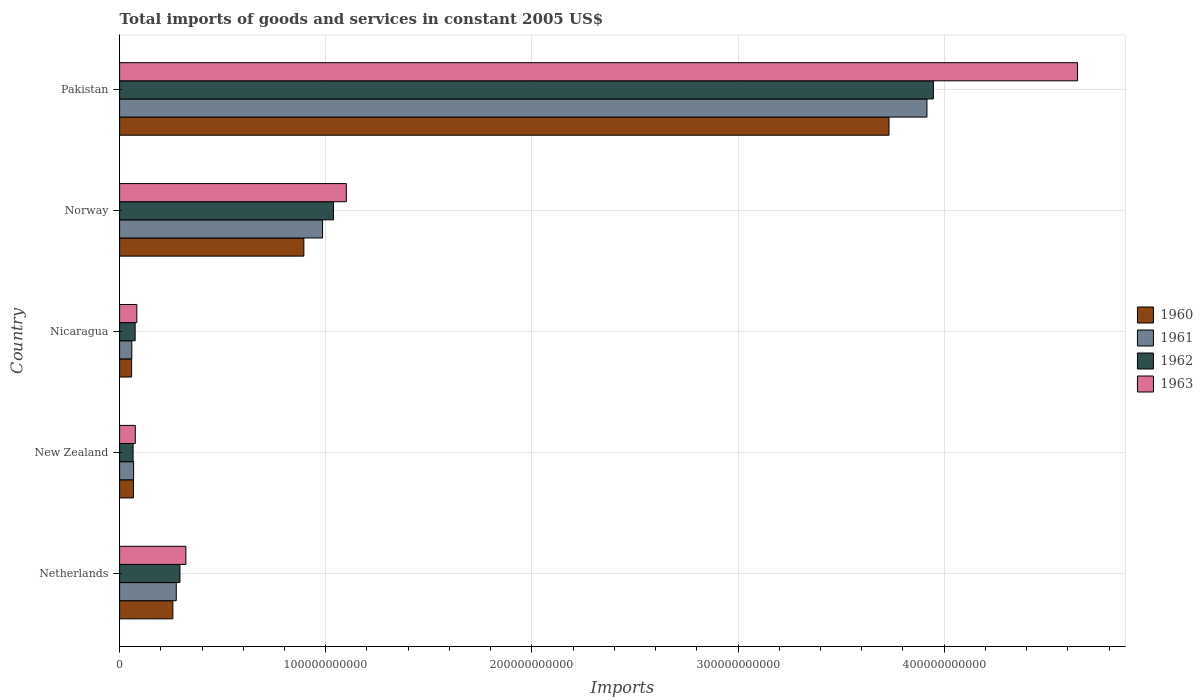How many different coloured bars are there?
Make the answer very short. 4. How many groups of bars are there?
Your answer should be compact. 5. Are the number of bars per tick equal to the number of legend labels?
Ensure brevity in your answer.  Yes. Are the number of bars on each tick of the Y-axis equal?
Ensure brevity in your answer.  Yes. How many bars are there on the 4th tick from the top?
Provide a short and direct response. 4. How many bars are there on the 2nd tick from the bottom?
Keep it short and to the point. 4. What is the total imports of goods and services in 1963 in Norway?
Provide a succinct answer. 1.10e+11. Across all countries, what is the maximum total imports of goods and services in 1962?
Provide a succinct answer. 3.95e+11. Across all countries, what is the minimum total imports of goods and services in 1963?
Your answer should be compact. 7.62e+09. In which country was the total imports of goods and services in 1961 minimum?
Make the answer very short. Nicaragua. What is the total total imports of goods and services in 1963 in the graph?
Offer a terse response. 6.23e+11. What is the difference between the total imports of goods and services in 1963 in Netherlands and that in New Zealand?
Your response must be concise. 2.45e+1. What is the difference between the total imports of goods and services in 1960 in Nicaragua and the total imports of goods and services in 1962 in New Zealand?
Ensure brevity in your answer.  -7.05e+08. What is the average total imports of goods and services in 1960 per country?
Give a very brief answer. 1.00e+11. What is the difference between the total imports of goods and services in 1961 and total imports of goods and services in 1960 in Norway?
Your response must be concise. 9.07e+09. In how many countries, is the total imports of goods and services in 1961 greater than 200000000000 US$?
Offer a very short reply. 1. What is the ratio of the total imports of goods and services in 1960 in New Zealand to that in Nicaragua?
Give a very brief answer. 1.15. Is the total imports of goods and services in 1961 in Netherlands less than that in Pakistan?
Your answer should be very brief. Yes. Is the difference between the total imports of goods and services in 1961 in Netherlands and Norway greater than the difference between the total imports of goods and services in 1960 in Netherlands and Norway?
Offer a terse response. No. What is the difference between the highest and the second highest total imports of goods and services in 1962?
Offer a terse response. 2.91e+11. What is the difference between the highest and the lowest total imports of goods and services in 1963?
Offer a very short reply. 4.57e+11. In how many countries, is the total imports of goods and services in 1960 greater than the average total imports of goods and services in 1960 taken over all countries?
Provide a short and direct response. 1. Is it the case that in every country, the sum of the total imports of goods and services in 1961 and total imports of goods and services in 1962 is greater than the sum of total imports of goods and services in 1963 and total imports of goods and services in 1960?
Your answer should be compact. No. What does the 1st bar from the bottom in Netherlands represents?
Ensure brevity in your answer.  1960. How many bars are there?
Give a very brief answer. 20. What is the difference between two consecutive major ticks on the X-axis?
Offer a terse response. 1.00e+11. How are the legend labels stacked?
Make the answer very short. Vertical. What is the title of the graph?
Offer a terse response. Total imports of goods and services in constant 2005 US$. Does "1972" appear as one of the legend labels in the graph?
Give a very brief answer. No. What is the label or title of the X-axis?
Make the answer very short. Imports. What is the Imports in 1960 in Netherlands?
Your response must be concise. 2.58e+1. What is the Imports of 1961 in Netherlands?
Keep it short and to the point. 2.75e+1. What is the Imports of 1962 in Netherlands?
Ensure brevity in your answer.  2.93e+1. What is the Imports of 1963 in Netherlands?
Provide a succinct answer. 3.21e+1. What is the Imports in 1960 in New Zealand?
Ensure brevity in your answer.  6.71e+09. What is the Imports in 1961 in New Zealand?
Provide a succinct answer. 6.81e+09. What is the Imports in 1962 in New Zealand?
Provide a short and direct response. 6.55e+09. What is the Imports of 1963 in New Zealand?
Keep it short and to the point. 7.62e+09. What is the Imports of 1960 in Nicaragua?
Your answer should be compact. 5.84e+09. What is the Imports in 1961 in Nicaragua?
Ensure brevity in your answer.  5.92e+09. What is the Imports in 1962 in Nicaragua?
Give a very brief answer. 7.54e+09. What is the Imports in 1963 in Nicaragua?
Your answer should be very brief. 8.36e+09. What is the Imports in 1960 in Norway?
Your answer should be very brief. 8.94e+1. What is the Imports in 1961 in Norway?
Your answer should be very brief. 9.85e+1. What is the Imports in 1962 in Norway?
Give a very brief answer. 1.04e+11. What is the Imports in 1963 in Norway?
Offer a very short reply. 1.10e+11. What is the Imports of 1960 in Pakistan?
Your response must be concise. 3.73e+11. What is the Imports in 1961 in Pakistan?
Provide a succinct answer. 3.92e+11. What is the Imports in 1962 in Pakistan?
Ensure brevity in your answer.  3.95e+11. What is the Imports in 1963 in Pakistan?
Provide a short and direct response. 4.65e+11. Across all countries, what is the maximum Imports of 1960?
Offer a terse response. 3.73e+11. Across all countries, what is the maximum Imports in 1961?
Your answer should be very brief. 3.92e+11. Across all countries, what is the maximum Imports of 1962?
Give a very brief answer. 3.95e+11. Across all countries, what is the maximum Imports in 1963?
Your answer should be compact. 4.65e+11. Across all countries, what is the minimum Imports of 1960?
Give a very brief answer. 5.84e+09. Across all countries, what is the minimum Imports in 1961?
Your answer should be compact. 5.92e+09. Across all countries, what is the minimum Imports of 1962?
Your answer should be compact. 6.55e+09. Across all countries, what is the minimum Imports in 1963?
Provide a succinct answer. 7.62e+09. What is the total Imports of 1960 in the graph?
Ensure brevity in your answer.  5.01e+11. What is the total Imports of 1961 in the graph?
Ensure brevity in your answer.  5.30e+11. What is the total Imports of 1962 in the graph?
Provide a succinct answer. 5.42e+11. What is the total Imports in 1963 in the graph?
Provide a short and direct response. 6.23e+11. What is the difference between the Imports of 1960 in Netherlands and that in New Zealand?
Give a very brief answer. 1.91e+1. What is the difference between the Imports in 1961 in Netherlands and that in New Zealand?
Your answer should be compact. 2.07e+1. What is the difference between the Imports of 1962 in Netherlands and that in New Zealand?
Your answer should be very brief. 2.27e+1. What is the difference between the Imports of 1963 in Netherlands and that in New Zealand?
Provide a short and direct response. 2.45e+1. What is the difference between the Imports of 1960 in Netherlands and that in Nicaragua?
Offer a very short reply. 2.00e+1. What is the difference between the Imports of 1961 in Netherlands and that in Nicaragua?
Keep it short and to the point. 2.16e+1. What is the difference between the Imports of 1962 in Netherlands and that in Nicaragua?
Keep it short and to the point. 2.17e+1. What is the difference between the Imports in 1963 in Netherlands and that in Nicaragua?
Give a very brief answer. 2.38e+1. What is the difference between the Imports of 1960 in Netherlands and that in Norway?
Your answer should be very brief. -6.35e+1. What is the difference between the Imports in 1961 in Netherlands and that in Norway?
Your response must be concise. -7.10e+1. What is the difference between the Imports of 1962 in Netherlands and that in Norway?
Your response must be concise. -7.45e+1. What is the difference between the Imports in 1963 in Netherlands and that in Norway?
Provide a succinct answer. -7.78e+1. What is the difference between the Imports in 1960 in Netherlands and that in Pakistan?
Keep it short and to the point. -3.47e+11. What is the difference between the Imports of 1961 in Netherlands and that in Pakistan?
Your answer should be very brief. -3.64e+11. What is the difference between the Imports in 1962 in Netherlands and that in Pakistan?
Offer a very short reply. -3.66e+11. What is the difference between the Imports in 1963 in Netherlands and that in Pakistan?
Your answer should be compact. -4.33e+11. What is the difference between the Imports of 1960 in New Zealand and that in Nicaragua?
Offer a terse response. 8.66e+08. What is the difference between the Imports of 1961 in New Zealand and that in Nicaragua?
Keep it short and to the point. 8.81e+08. What is the difference between the Imports in 1962 in New Zealand and that in Nicaragua?
Your answer should be very brief. -9.91e+08. What is the difference between the Imports of 1963 in New Zealand and that in Nicaragua?
Your answer should be very brief. -7.46e+08. What is the difference between the Imports in 1960 in New Zealand and that in Norway?
Provide a short and direct response. -8.27e+1. What is the difference between the Imports in 1961 in New Zealand and that in Norway?
Your response must be concise. -9.17e+1. What is the difference between the Imports of 1962 in New Zealand and that in Norway?
Keep it short and to the point. -9.72e+1. What is the difference between the Imports of 1963 in New Zealand and that in Norway?
Keep it short and to the point. -1.02e+11. What is the difference between the Imports in 1960 in New Zealand and that in Pakistan?
Your answer should be compact. -3.67e+11. What is the difference between the Imports in 1961 in New Zealand and that in Pakistan?
Provide a short and direct response. -3.85e+11. What is the difference between the Imports of 1962 in New Zealand and that in Pakistan?
Provide a short and direct response. -3.88e+11. What is the difference between the Imports of 1963 in New Zealand and that in Pakistan?
Give a very brief answer. -4.57e+11. What is the difference between the Imports in 1960 in Nicaragua and that in Norway?
Provide a short and direct response. -8.35e+1. What is the difference between the Imports of 1961 in Nicaragua and that in Norway?
Ensure brevity in your answer.  -9.25e+1. What is the difference between the Imports in 1962 in Nicaragua and that in Norway?
Keep it short and to the point. -9.62e+1. What is the difference between the Imports of 1963 in Nicaragua and that in Norway?
Offer a terse response. -1.02e+11. What is the difference between the Imports of 1960 in Nicaragua and that in Pakistan?
Your answer should be very brief. -3.67e+11. What is the difference between the Imports in 1961 in Nicaragua and that in Pakistan?
Offer a very short reply. -3.86e+11. What is the difference between the Imports of 1962 in Nicaragua and that in Pakistan?
Your response must be concise. -3.87e+11. What is the difference between the Imports of 1963 in Nicaragua and that in Pakistan?
Keep it short and to the point. -4.56e+11. What is the difference between the Imports in 1960 in Norway and that in Pakistan?
Ensure brevity in your answer.  -2.84e+11. What is the difference between the Imports in 1961 in Norway and that in Pakistan?
Your answer should be compact. -2.93e+11. What is the difference between the Imports in 1962 in Norway and that in Pakistan?
Provide a short and direct response. -2.91e+11. What is the difference between the Imports in 1963 in Norway and that in Pakistan?
Offer a very short reply. -3.55e+11. What is the difference between the Imports of 1960 in Netherlands and the Imports of 1961 in New Zealand?
Keep it short and to the point. 1.90e+1. What is the difference between the Imports of 1960 in Netherlands and the Imports of 1962 in New Zealand?
Provide a short and direct response. 1.93e+1. What is the difference between the Imports of 1960 in Netherlands and the Imports of 1963 in New Zealand?
Provide a succinct answer. 1.82e+1. What is the difference between the Imports in 1961 in Netherlands and the Imports in 1962 in New Zealand?
Offer a terse response. 2.10e+1. What is the difference between the Imports of 1961 in Netherlands and the Imports of 1963 in New Zealand?
Give a very brief answer. 1.99e+1. What is the difference between the Imports of 1962 in Netherlands and the Imports of 1963 in New Zealand?
Offer a terse response. 2.17e+1. What is the difference between the Imports of 1960 in Netherlands and the Imports of 1961 in Nicaragua?
Keep it short and to the point. 1.99e+1. What is the difference between the Imports in 1960 in Netherlands and the Imports in 1962 in Nicaragua?
Provide a short and direct response. 1.83e+1. What is the difference between the Imports of 1960 in Netherlands and the Imports of 1963 in Nicaragua?
Your answer should be compact. 1.75e+1. What is the difference between the Imports in 1961 in Netherlands and the Imports in 1962 in Nicaragua?
Your response must be concise. 2.00e+1. What is the difference between the Imports in 1961 in Netherlands and the Imports in 1963 in Nicaragua?
Give a very brief answer. 1.91e+1. What is the difference between the Imports in 1962 in Netherlands and the Imports in 1963 in Nicaragua?
Your answer should be very brief. 2.09e+1. What is the difference between the Imports in 1960 in Netherlands and the Imports in 1961 in Norway?
Your answer should be very brief. -7.26e+1. What is the difference between the Imports in 1960 in Netherlands and the Imports in 1962 in Norway?
Your answer should be compact. -7.79e+1. What is the difference between the Imports of 1960 in Netherlands and the Imports of 1963 in Norway?
Give a very brief answer. -8.41e+1. What is the difference between the Imports in 1961 in Netherlands and the Imports in 1962 in Norway?
Your answer should be compact. -7.62e+1. What is the difference between the Imports in 1961 in Netherlands and the Imports in 1963 in Norway?
Your answer should be compact. -8.25e+1. What is the difference between the Imports of 1962 in Netherlands and the Imports of 1963 in Norway?
Give a very brief answer. -8.07e+1. What is the difference between the Imports of 1960 in Netherlands and the Imports of 1961 in Pakistan?
Provide a short and direct response. -3.66e+11. What is the difference between the Imports of 1960 in Netherlands and the Imports of 1962 in Pakistan?
Your answer should be compact. -3.69e+11. What is the difference between the Imports of 1960 in Netherlands and the Imports of 1963 in Pakistan?
Ensure brevity in your answer.  -4.39e+11. What is the difference between the Imports in 1961 in Netherlands and the Imports in 1962 in Pakistan?
Make the answer very short. -3.67e+11. What is the difference between the Imports of 1961 in Netherlands and the Imports of 1963 in Pakistan?
Your answer should be very brief. -4.37e+11. What is the difference between the Imports of 1962 in Netherlands and the Imports of 1963 in Pakistan?
Provide a short and direct response. -4.35e+11. What is the difference between the Imports of 1960 in New Zealand and the Imports of 1961 in Nicaragua?
Make the answer very short. 7.83e+08. What is the difference between the Imports in 1960 in New Zealand and the Imports in 1962 in Nicaragua?
Provide a short and direct response. -8.30e+08. What is the difference between the Imports in 1960 in New Zealand and the Imports in 1963 in Nicaragua?
Make the answer very short. -1.66e+09. What is the difference between the Imports of 1961 in New Zealand and the Imports of 1962 in Nicaragua?
Ensure brevity in your answer.  -7.32e+08. What is the difference between the Imports of 1961 in New Zealand and the Imports of 1963 in Nicaragua?
Provide a succinct answer. -1.56e+09. What is the difference between the Imports of 1962 in New Zealand and the Imports of 1963 in Nicaragua?
Your response must be concise. -1.82e+09. What is the difference between the Imports of 1960 in New Zealand and the Imports of 1961 in Norway?
Offer a very short reply. -9.18e+1. What is the difference between the Imports in 1960 in New Zealand and the Imports in 1962 in Norway?
Offer a very short reply. -9.70e+1. What is the difference between the Imports of 1960 in New Zealand and the Imports of 1963 in Norway?
Your response must be concise. -1.03e+11. What is the difference between the Imports in 1961 in New Zealand and the Imports in 1962 in Norway?
Offer a terse response. -9.69e+1. What is the difference between the Imports in 1961 in New Zealand and the Imports in 1963 in Norway?
Your answer should be very brief. -1.03e+11. What is the difference between the Imports in 1962 in New Zealand and the Imports in 1963 in Norway?
Your response must be concise. -1.03e+11. What is the difference between the Imports of 1960 in New Zealand and the Imports of 1961 in Pakistan?
Keep it short and to the point. -3.85e+11. What is the difference between the Imports in 1960 in New Zealand and the Imports in 1962 in Pakistan?
Your answer should be compact. -3.88e+11. What is the difference between the Imports in 1960 in New Zealand and the Imports in 1963 in Pakistan?
Keep it short and to the point. -4.58e+11. What is the difference between the Imports of 1961 in New Zealand and the Imports of 1962 in Pakistan?
Offer a very short reply. -3.88e+11. What is the difference between the Imports in 1961 in New Zealand and the Imports in 1963 in Pakistan?
Give a very brief answer. -4.58e+11. What is the difference between the Imports of 1962 in New Zealand and the Imports of 1963 in Pakistan?
Your answer should be compact. -4.58e+11. What is the difference between the Imports in 1960 in Nicaragua and the Imports in 1961 in Norway?
Offer a very short reply. -9.26e+1. What is the difference between the Imports of 1960 in Nicaragua and the Imports of 1962 in Norway?
Your answer should be compact. -9.79e+1. What is the difference between the Imports of 1960 in Nicaragua and the Imports of 1963 in Norway?
Your answer should be compact. -1.04e+11. What is the difference between the Imports in 1961 in Nicaragua and the Imports in 1962 in Norway?
Offer a very short reply. -9.78e+1. What is the difference between the Imports of 1961 in Nicaragua and the Imports of 1963 in Norway?
Your response must be concise. -1.04e+11. What is the difference between the Imports in 1962 in Nicaragua and the Imports in 1963 in Norway?
Keep it short and to the point. -1.02e+11. What is the difference between the Imports in 1960 in Nicaragua and the Imports in 1961 in Pakistan?
Give a very brief answer. -3.86e+11. What is the difference between the Imports of 1960 in Nicaragua and the Imports of 1962 in Pakistan?
Your answer should be very brief. -3.89e+11. What is the difference between the Imports of 1960 in Nicaragua and the Imports of 1963 in Pakistan?
Offer a terse response. -4.59e+11. What is the difference between the Imports of 1961 in Nicaragua and the Imports of 1962 in Pakistan?
Give a very brief answer. -3.89e+11. What is the difference between the Imports in 1961 in Nicaragua and the Imports in 1963 in Pakistan?
Provide a succinct answer. -4.59e+11. What is the difference between the Imports in 1962 in Nicaragua and the Imports in 1963 in Pakistan?
Provide a succinct answer. -4.57e+11. What is the difference between the Imports of 1960 in Norway and the Imports of 1961 in Pakistan?
Keep it short and to the point. -3.02e+11. What is the difference between the Imports in 1960 in Norway and the Imports in 1962 in Pakistan?
Your answer should be compact. -3.05e+11. What is the difference between the Imports of 1960 in Norway and the Imports of 1963 in Pakistan?
Your response must be concise. -3.75e+11. What is the difference between the Imports in 1961 in Norway and the Imports in 1962 in Pakistan?
Offer a terse response. -2.96e+11. What is the difference between the Imports of 1961 in Norway and the Imports of 1963 in Pakistan?
Make the answer very short. -3.66e+11. What is the difference between the Imports in 1962 in Norway and the Imports in 1963 in Pakistan?
Give a very brief answer. -3.61e+11. What is the average Imports of 1960 per country?
Offer a terse response. 1.00e+11. What is the average Imports in 1961 per country?
Provide a succinct answer. 1.06e+11. What is the average Imports of 1962 per country?
Your response must be concise. 1.08e+11. What is the average Imports of 1963 per country?
Your answer should be compact. 1.25e+11. What is the difference between the Imports of 1960 and Imports of 1961 in Netherlands?
Your answer should be very brief. -1.65e+09. What is the difference between the Imports of 1960 and Imports of 1962 in Netherlands?
Offer a terse response. -3.43e+09. What is the difference between the Imports of 1960 and Imports of 1963 in Netherlands?
Your response must be concise. -6.30e+09. What is the difference between the Imports in 1961 and Imports in 1962 in Netherlands?
Provide a succinct answer. -1.77e+09. What is the difference between the Imports in 1961 and Imports in 1963 in Netherlands?
Your response must be concise. -4.65e+09. What is the difference between the Imports in 1962 and Imports in 1963 in Netherlands?
Offer a terse response. -2.87e+09. What is the difference between the Imports of 1960 and Imports of 1961 in New Zealand?
Provide a succinct answer. -9.87e+07. What is the difference between the Imports of 1960 and Imports of 1962 in New Zealand?
Give a very brief answer. 1.61e+08. What is the difference between the Imports of 1960 and Imports of 1963 in New Zealand?
Your answer should be compact. -9.09e+08. What is the difference between the Imports of 1961 and Imports of 1962 in New Zealand?
Ensure brevity in your answer.  2.60e+08. What is the difference between the Imports of 1961 and Imports of 1963 in New Zealand?
Provide a short and direct response. -8.10e+08. What is the difference between the Imports of 1962 and Imports of 1963 in New Zealand?
Make the answer very short. -1.07e+09. What is the difference between the Imports of 1960 and Imports of 1961 in Nicaragua?
Provide a short and direct response. -8.34e+07. What is the difference between the Imports in 1960 and Imports in 1962 in Nicaragua?
Your answer should be very brief. -1.70e+09. What is the difference between the Imports in 1960 and Imports in 1963 in Nicaragua?
Make the answer very short. -2.52e+09. What is the difference between the Imports in 1961 and Imports in 1962 in Nicaragua?
Make the answer very short. -1.61e+09. What is the difference between the Imports of 1961 and Imports of 1963 in Nicaragua?
Ensure brevity in your answer.  -2.44e+09. What is the difference between the Imports of 1962 and Imports of 1963 in Nicaragua?
Provide a succinct answer. -8.25e+08. What is the difference between the Imports of 1960 and Imports of 1961 in Norway?
Your answer should be compact. -9.07e+09. What is the difference between the Imports in 1960 and Imports in 1962 in Norway?
Keep it short and to the point. -1.44e+1. What is the difference between the Imports of 1960 and Imports of 1963 in Norway?
Provide a succinct answer. -2.06e+1. What is the difference between the Imports of 1961 and Imports of 1962 in Norway?
Your response must be concise. -5.28e+09. What is the difference between the Imports of 1961 and Imports of 1963 in Norway?
Give a very brief answer. -1.15e+1. What is the difference between the Imports of 1962 and Imports of 1963 in Norway?
Your response must be concise. -6.24e+09. What is the difference between the Imports in 1960 and Imports in 1961 in Pakistan?
Keep it short and to the point. -1.84e+1. What is the difference between the Imports of 1960 and Imports of 1962 in Pakistan?
Keep it short and to the point. -2.15e+1. What is the difference between the Imports in 1960 and Imports in 1963 in Pakistan?
Ensure brevity in your answer.  -9.14e+1. What is the difference between the Imports of 1961 and Imports of 1962 in Pakistan?
Ensure brevity in your answer.  -3.12e+09. What is the difference between the Imports in 1961 and Imports in 1963 in Pakistan?
Your answer should be compact. -7.30e+1. What is the difference between the Imports of 1962 and Imports of 1963 in Pakistan?
Make the answer very short. -6.99e+1. What is the ratio of the Imports in 1960 in Netherlands to that in New Zealand?
Ensure brevity in your answer.  3.85. What is the ratio of the Imports in 1961 in Netherlands to that in New Zealand?
Your response must be concise. 4.04. What is the ratio of the Imports in 1962 in Netherlands to that in New Zealand?
Your response must be concise. 4.47. What is the ratio of the Imports of 1963 in Netherlands to that in New Zealand?
Give a very brief answer. 4.22. What is the ratio of the Imports of 1960 in Netherlands to that in Nicaragua?
Offer a very short reply. 4.42. What is the ratio of the Imports of 1961 in Netherlands to that in Nicaragua?
Offer a very short reply. 4.64. What is the ratio of the Imports in 1962 in Netherlands to that in Nicaragua?
Keep it short and to the point. 3.88. What is the ratio of the Imports of 1963 in Netherlands to that in Nicaragua?
Give a very brief answer. 3.84. What is the ratio of the Imports of 1960 in Netherlands to that in Norway?
Your answer should be compact. 0.29. What is the ratio of the Imports of 1961 in Netherlands to that in Norway?
Give a very brief answer. 0.28. What is the ratio of the Imports in 1962 in Netherlands to that in Norway?
Offer a terse response. 0.28. What is the ratio of the Imports in 1963 in Netherlands to that in Norway?
Your answer should be very brief. 0.29. What is the ratio of the Imports in 1960 in Netherlands to that in Pakistan?
Give a very brief answer. 0.07. What is the ratio of the Imports of 1961 in Netherlands to that in Pakistan?
Your answer should be very brief. 0.07. What is the ratio of the Imports of 1962 in Netherlands to that in Pakistan?
Your answer should be very brief. 0.07. What is the ratio of the Imports of 1963 in Netherlands to that in Pakistan?
Offer a very short reply. 0.07. What is the ratio of the Imports in 1960 in New Zealand to that in Nicaragua?
Make the answer very short. 1.15. What is the ratio of the Imports of 1961 in New Zealand to that in Nicaragua?
Your response must be concise. 1.15. What is the ratio of the Imports in 1962 in New Zealand to that in Nicaragua?
Offer a terse response. 0.87. What is the ratio of the Imports in 1963 in New Zealand to that in Nicaragua?
Provide a succinct answer. 0.91. What is the ratio of the Imports of 1960 in New Zealand to that in Norway?
Give a very brief answer. 0.07. What is the ratio of the Imports of 1961 in New Zealand to that in Norway?
Ensure brevity in your answer.  0.07. What is the ratio of the Imports in 1962 in New Zealand to that in Norway?
Offer a very short reply. 0.06. What is the ratio of the Imports in 1963 in New Zealand to that in Norway?
Offer a very short reply. 0.07. What is the ratio of the Imports in 1960 in New Zealand to that in Pakistan?
Offer a terse response. 0.02. What is the ratio of the Imports in 1961 in New Zealand to that in Pakistan?
Make the answer very short. 0.02. What is the ratio of the Imports in 1962 in New Zealand to that in Pakistan?
Offer a very short reply. 0.02. What is the ratio of the Imports in 1963 in New Zealand to that in Pakistan?
Provide a succinct answer. 0.02. What is the ratio of the Imports in 1960 in Nicaragua to that in Norway?
Make the answer very short. 0.07. What is the ratio of the Imports of 1961 in Nicaragua to that in Norway?
Give a very brief answer. 0.06. What is the ratio of the Imports of 1962 in Nicaragua to that in Norway?
Offer a very short reply. 0.07. What is the ratio of the Imports in 1963 in Nicaragua to that in Norway?
Give a very brief answer. 0.08. What is the ratio of the Imports in 1960 in Nicaragua to that in Pakistan?
Your answer should be compact. 0.02. What is the ratio of the Imports of 1961 in Nicaragua to that in Pakistan?
Your answer should be compact. 0.02. What is the ratio of the Imports of 1962 in Nicaragua to that in Pakistan?
Offer a terse response. 0.02. What is the ratio of the Imports in 1963 in Nicaragua to that in Pakistan?
Offer a terse response. 0.02. What is the ratio of the Imports of 1960 in Norway to that in Pakistan?
Give a very brief answer. 0.24. What is the ratio of the Imports of 1961 in Norway to that in Pakistan?
Give a very brief answer. 0.25. What is the ratio of the Imports of 1962 in Norway to that in Pakistan?
Offer a very short reply. 0.26. What is the ratio of the Imports in 1963 in Norway to that in Pakistan?
Your answer should be compact. 0.24. What is the difference between the highest and the second highest Imports in 1960?
Make the answer very short. 2.84e+11. What is the difference between the highest and the second highest Imports in 1961?
Your answer should be very brief. 2.93e+11. What is the difference between the highest and the second highest Imports of 1962?
Provide a short and direct response. 2.91e+11. What is the difference between the highest and the second highest Imports in 1963?
Your response must be concise. 3.55e+11. What is the difference between the highest and the lowest Imports of 1960?
Your answer should be compact. 3.67e+11. What is the difference between the highest and the lowest Imports of 1961?
Offer a terse response. 3.86e+11. What is the difference between the highest and the lowest Imports of 1962?
Keep it short and to the point. 3.88e+11. What is the difference between the highest and the lowest Imports of 1963?
Offer a terse response. 4.57e+11. 